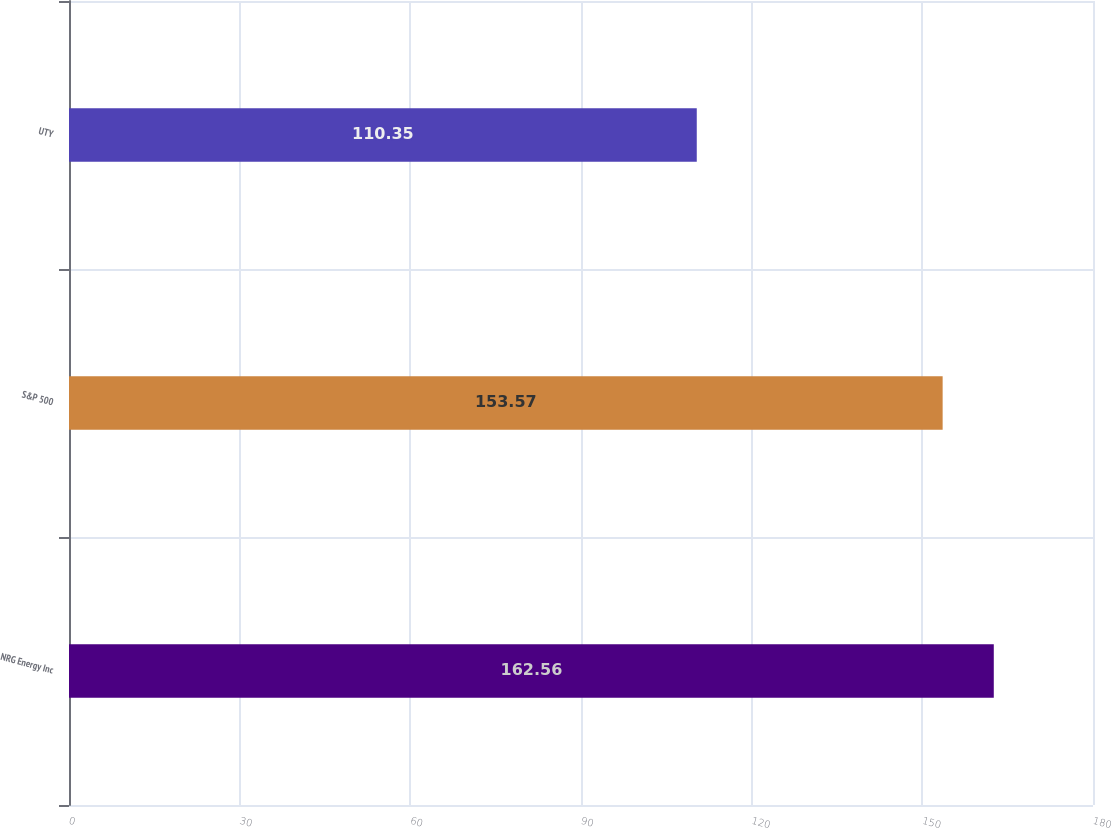Convert chart to OTSL. <chart><loc_0><loc_0><loc_500><loc_500><bar_chart><fcel>NRG Energy Inc<fcel>S&P 500<fcel>UTY<nl><fcel>162.56<fcel>153.57<fcel>110.35<nl></chart> 